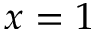Convert formula to latex. <formula><loc_0><loc_0><loc_500><loc_500>x = 1</formula> 